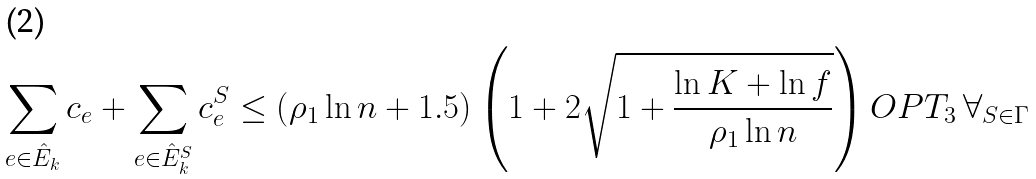<formula> <loc_0><loc_0><loc_500><loc_500>\sum _ { e \in \hat { E } _ { k } } c _ { e } + \sum _ { e \in \hat { E } ^ { S } _ { k } } c ^ { S } _ { e } \leq \left ( \rho _ { 1 } \ln n + 1 . 5 \right ) \left ( 1 + 2 \sqrt { 1 + \frac { \ln K + \ln f } { \rho _ { 1 } \ln n } } \right ) O P T _ { 3 } \, \forall _ { S \in \Gamma }</formula> 